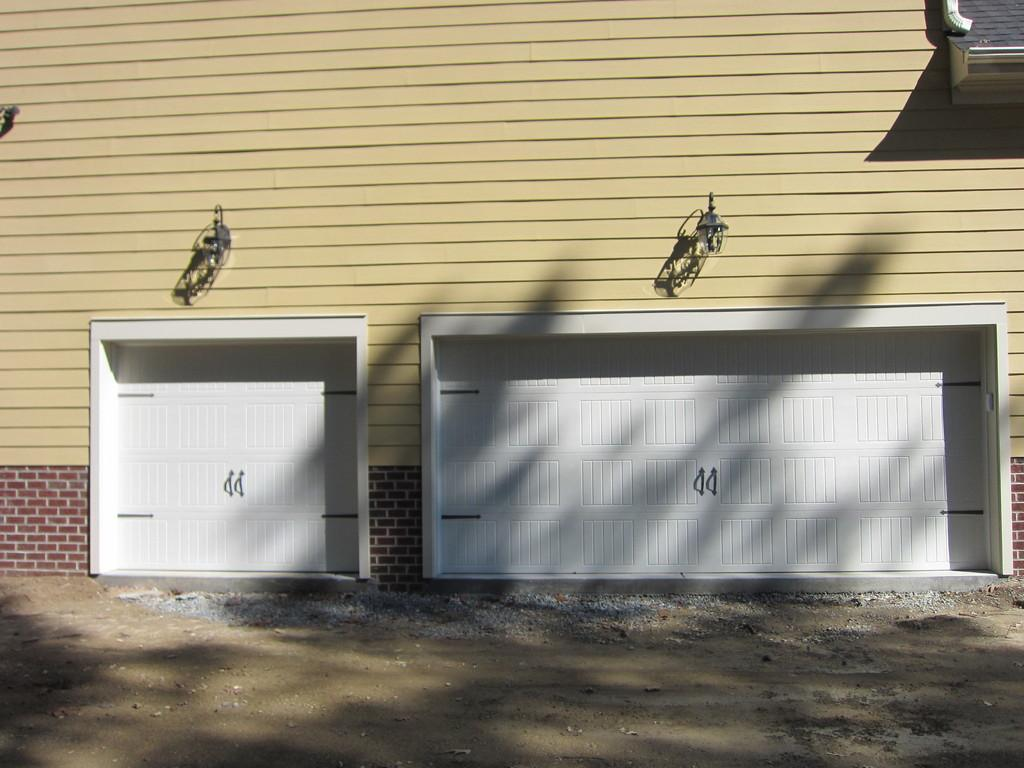What color are the garage doors in the image? The garage doors are white in the image. What color is the wall behind the garage doors? The wall behind the garage doors is yellow. How many hanging lights are visible in the image? There are two hanging lights visible in the image. What is visible at the bottom of the image? There is a ground visible at the bottom of the image. Can you describe the lizards crawling on the garage doors in the image? There are no lizards present in the image; the garage doors are white on a yellow wall. What type of haircut does the person in the image have? There is no person present in the image, so it is not possible to describe their haircut. 